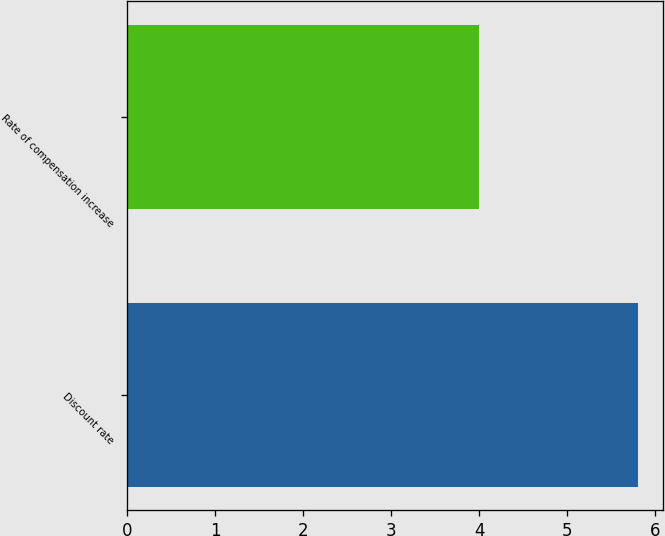<chart> <loc_0><loc_0><loc_500><loc_500><bar_chart><fcel>Discount rate<fcel>Rate of compensation increase<nl><fcel>5.8<fcel>4<nl></chart> 